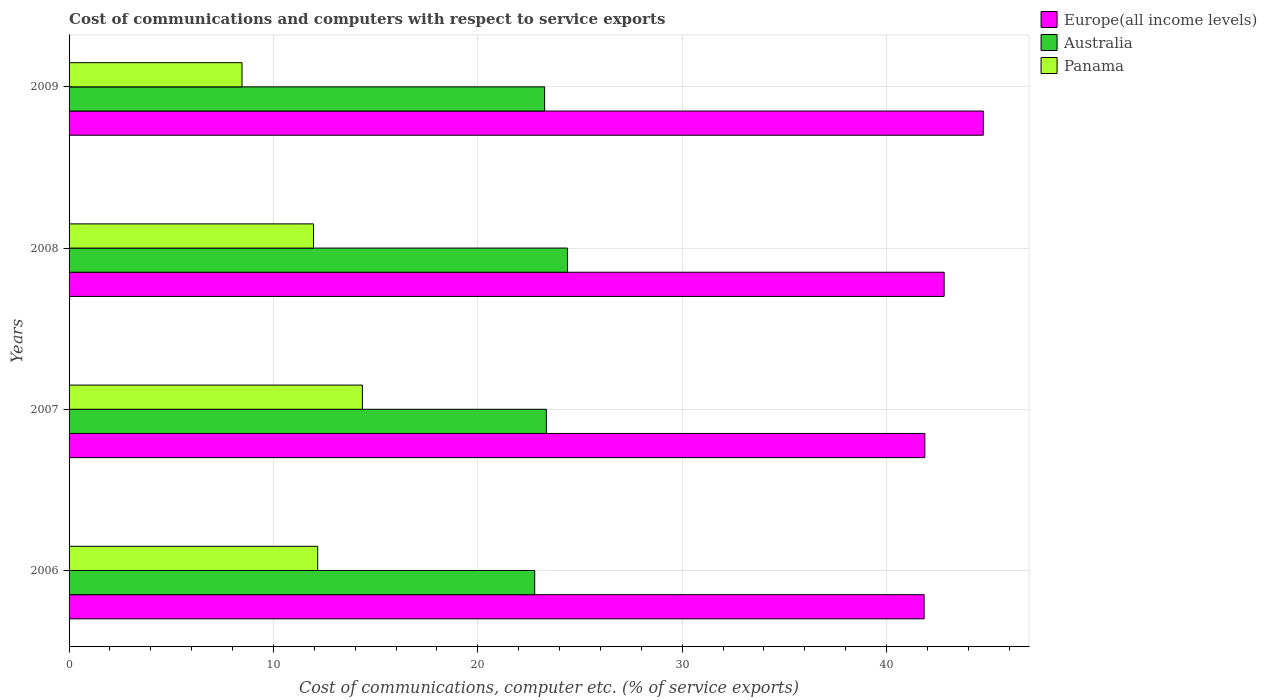How many different coloured bars are there?
Your answer should be compact. 3. How many bars are there on the 1st tick from the top?
Your response must be concise. 3. How many bars are there on the 4th tick from the bottom?
Ensure brevity in your answer.  3. What is the label of the 1st group of bars from the top?
Give a very brief answer. 2009. In how many cases, is the number of bars for a given year not equal to the number of legend labels?
Offer a very short reply. 0. What is the cost of communications and computers in Europe(all income levels) in 2007?
Keep it short and to the point. 41.88. Across all years, what is the maximum cost of communications and computers in Australia?
Give a very brief answer. 24.39. Across all years, what is the minimum cost of communications and computers in Europe(all income levels)?
Your answer should be compact. 41.84. In which year was the cost of communications and computers in Australia maximum?
Your answer should be very brief. 2008. In which year was the cost of communications and computers in Europe(all income levels) minimum?
Your answer should be compact. 2006. What is the total cost of communications and computers in Europe(all income levels) in the graph?
Offer a terse response. 171.28. What is the difference between the cost of communications and computers in Panama in 2007 and that in 2008?
Your answer should be compact. 2.39. What is the difference between the cost of communications and computers in Europe(all income levels) in 2006 and the cost of communications and computers in Panama in 2009?
Give a very brief answer. 33.38. What is the average cost of communications and computers in Europe(all income levels) per year?
Offer a very short reply. 42.82. In the year 2007, what is the difference between the cost of communications and computers in Panama and cost of communications and computers in Australia?
Offer a terse response. -9. What is the ratio of the cost of communications and computers in Panama in 2006 to that in 2008?
Offer a very short reply. 1.02. Is the cost of communications and computers in Panama in 2006 less than that in 2009?
Give a very brief answer. No. What is the difference between the highest and the second highest cost of communications and computers in Panama?
Give a very brief answer. 2.19. What is the difference between the highest and the lowest cost of communications and computers in Europe(all income levels)?
Keep it short and to the point. 2.9. What does the 2nd bar from the top in 2009 represents?
Your answer should be very brief. Australia. What does the 1st bar from the bottom in 2008 represents?
Offer a terse response. Europe(all income levels). Is it the case that in every year, the sum of the cost of communications and computers in Australia and cost of communications and computers in Panama is greater than the cost of communications and computers in Europe(all income levels)?
Keep it short and to the point. No. How many bars are there?
Give a very brief answer. 12. Are all the bars in the graph horizontal?
Make the answer very short. Yes. What is the difference between two consecutive major ticks on the X-axis?
Offer a terse response. 10. Where does the legend appear in the graph?
Give a very brief answer. Top right. What is the title of the graph?
Your answer should be compact. Cost of communications and computers with respect to service exports. What is the label or title of the X-axis?
Offer a terse response. Cost of communications, computer etc. (% of service exports). What is the label or title of the Y-axis?
Ensure brevity in your answer.  Years. What is the Cost of communications, computer etc. (% of service exports) of Europe(all income levels) in 2006?
Offer a terse response. 41.84. What is the Cost of communications, computer etc. (% of service exports) in Australia in 2006?
Make the answer very short. 22.79. What is the Cost of communications, computer etc. (% of service exports) in Panama in 2006?
Ensure brevity in your answer.  12.17. What is the Cost of communications, computer etc. (% of service exports) in Europe(all income levels) in 2007?
Your answer should be very brief. 41.88. What is the Cost of communications, computer etc. (% of service exports) of Australia in 2007?
Your answer should be very brief. 23.36. What is the Cost of communications, computer etc. (% of service exports) of Panama in 2007?
Your response must be concise. 14.35. What is the Cost of communications, computer etc. (% of service exports) of Europe(all income levels) in 2008?
Give a very brief answer. 42.82. What is the Cost of communications, computer etc. (% of service exports) in Australia in 2008?
Ensure brevity in your answer.  24.39. What is the Cost of communications, computer etc. (% of service exports) of Panama in 2008?
Give a very brief answer. 11.96. What is the Cost of communications, computer etc. (% of service exports) of Europe(all income levels) in 2009?
Keep it short and to the point. 44.74. What is the Cost of communications, computer etc. (% of service exports) of Australia in 2009?
Offer a very short reply. 23.27. What is the Cost of communications, computer etc. (% of service exports) in Panama in 2009?
Offer a terse response. 8.46. Across all years, what is the maximum Cost of communications, computer etc. (% of service exports) of Europe(all income levels)?
Your answer should be very brief. 44.74. Across all years, what is the maximum Cost of communications, computer etc. (% of service exports) of Australia?
Provide a succinct answer. 24.39. Across all years, what is the maximum Cost of communications, computer etc. (% of service exports) of Panama?
Your response must be concise. 14.35. Across all years, what is the minimum Cost of communications, computer etc. (% of service exports) in Europe(all income levels)?
Offer a terse response. 41.84. Across all years, what is the minimum Cost of communications, computer etc. (% of service exports) in Australia?
Give a very brief answer. 22.79. Across all years, what is the minimum Cost of communications, computer etc. (% of service exports) of Panama?
Give a very brief answer. 8.46. What is the total Cost of communications, computer etc. (% of service exports) in Europe(all income levels) in the graph?
Offer a terse response. 171.28. What is the total Cost of communications, computer etc. (% of service exports) in Australia in the graph?
Your response must be concise. 93.81. What is the total Cost of communications, computer etc. (% of service exports) of Panama in the graph?
Offer a terse response. 46.94. What is the difference between the Cost of communications, computer etc. (% of service exports) in Europe(all income levels) in 2006 and that in 2007?
Offer a very short reply. -0.04. What is the difference between the Cost of communications, computer etc. (% of service exports) in Australia in 2006 and that in 2007?
Give a very brief answer. -0.57. What is the difference between the Cost of communications, computer etc. (% of service exports) of Panama in 2006 and that in 2007?
Provide a short and direct response. -2.19. What is the difference between the Cost of communications, computer etc. (% of service exports) of Europe(all income levels) in 2006 and that in 2008?
Offer a very short reply. -0.98. What is the difference between the Cost of communications, computer etc. (% of service exports) in Australia in 2006 and that in 2008?
Offer a terse response. -1.61. What is the difference between the Cost of communications, computer etc. (% of service exports) of Panama in 2006 and that in 2008?
Give a very brief answer. 0.2. What is the difference between the Cost of communications, computer etc. (% of service exports) of Europe(all income levels) in 2006 and that in 2009?
Your answer should be compact. -2.9. What is the difference between the Cost of communications, computer etc. (% of service exports) in Australia in 2006 and that in 2009?
Your answer should be compact. -0.48. What is the difference between the Cost of communications, computer etc. (% of service exports) of Panama in 2006 and that in 2009?
Give a very brief answer. 3.7. What is the difference between the Cost of communications, computer etc. (% of service exports) of Europe(all income levels) in 2007 and that in 2008?
Keep it short and to the point. -0.94. What is the difference between the Cost of communications, computer etc. (% of service exports) of Australia in 2007 and that in 2008?
Ensure brevity in your answer.  -1.04. What is the difference between the Cost of communications, computer etc. (% of service exports) of Panama in 2007 and that in 2008?
Make the answer very short. 2.39. What is the difference between the Cost of communications, computer etc. (% of service exports) in Europe(all income levels) in 2007 and that in 2009?
Offer a terse response. -2.86. What is the difference between the Cost of communications, computer etc. (% of service exports) in Australia in 2007 and that in 2009?
Offer a terse response. 0.09. What is the difference between the Cost of communications, computer etc. (% of service exports) of Panama in 2007 and that in 2009?
Make the answer very short. 5.89. What is the difference between the Cost of communications, computer etc. (% of service exports) in Europe(all income levels) in 2008 and that in 2009?
Your answer should be very brief. -1.92. What is the difference between the Cost of communications, computer etc. (% of service exports) in Australia in 2008 and that in 2009?
Offer a terse response. 1.12. What is the difference between the Cost of communications, computer etc. (% of service exports) in Panama in 2008 and that in 2009?
Provide a short and direct response. 3.5. What is the difference between the Cost of communications, computer etc. (% of service exports) of Europe(all income levels) in 2006 and the Cost of communications, computer etc. (% of service exports) of Australia in 2007?
Offer a very short reply. 18.48. What is the difference between the Cost of communications, computer etc. (% of service exports) of Europe(all income levels) in 2006 and the Cost of communications, computer etc. (% of service exports) of Panama in 2007?
Your answer should be very brief. 27.49. What is the difference between the Cost of communications, computer etc. (% of service exports) of Australia in 2006 and the Cost of communications, computer etc. (% of service exports) of Panama in 2007?
Offer a terse response. 8.43. What is the difference between the Cost of communications, computer etc. (% of service exports) of Europe(all income levels) in 2006 and the Cost of communications, computer etc. (% of service exports) of Australia in 2008?
Give a very brief answer. 17.45. What is the difference between the Cost of communications, computer etc. (% of service exports) in Europe(all income levels) in 2006 and the Cost of communications, computer etc. (% of service exports) in Panama in 2008?
Offer a very short reply. 29.88. What is the difference between the Cost of communications, computer etc. (% of service exports) in Australia in 2006 and the Cost of communications, computer etc. (% of service exports) in Panama in 2008?
Ensure brevity in your answer.  10.82. What is the difference between the Cost of communications, computer etc. (% of service exports) of Europe(all income levels) in 2006 and the Cost of communications, computer etc. (% of service exports) of Australia in 2009?
Provide a succinct answer. 18.57. What is the difference between the Cost of communications, computer etc. (% of service exports) in Europe(all income levels) in 2006 and the Cost of communications, computer etc. (% of service exports) in Panama in 2009?
Keep it short and to the point. 33.38. What is the difference between the Cost of communications, computer etc. (% of service exports) in Australia in 2006 and the Cost of communications, computer etc. (% of service exports) in Panama in 2009?
Make the answer very short. 14.32. What is the difference between the Cost of communications, computer etc. (% of service exports) in Europe(all income levels) in 2007 and the Cost of communications, computer etc. (% of service exports) in Australia in 2008?
Provide a succinct answer. 17.49. What is the difference between the Cost of communications, computer etc. (% of service exports) in Europe(all income levels) in 2007 and the Cost of communications, computer etc. (% of service exports) in Panama in 2008?
Your answer should be very brief. 29.92. What is the difference between the Cost of communications, computer etc. (% of service exports) in Australia in 2007 and the Cost of communications, computer etc. (% of service exports) in Panama in 2008?
Offer a very short reply. 11.39. What is the difference between the Cost of communications, computer etc. (% of service exports) in Europe(all income levels) in 2007 and the Cost of communications, computer etc. (% of service exports) in Australia in 2009?
Your answer should be compact. 18.61. What is the difference between the Cost of communications, computer etc. (% of service exports) in Europe(all income levels) in 2007 and the Cost of communications, computer etc. (% of service exports) in Panama in 2009?
Your answer should be compact. 33.42. What is the difference between the Cost of communications, computer etc. (% of service exports) of Australia in 2007 and the Cost of communications, computer etc. (% of service exports) of Panama in 2009?
Keep it short and to the point. 14.89. What is the difference between the Cost of communications, computer etc. (% of service exports) of Europe(all income levels) in 2008 and the Cost of communications, computer etc. (% of service exports) of Australia in 2009?
Keep it short and to the point. 19.55. What is the difference between the Cost of communications, computer etc. (% of service exports) in Europe(all income levels) in 2008 and the Cost of communications, computer etc. (% of service exports) in Panama in 2009?
Ensure brevity in your answer.  34.36. What is the difference between the Cost of communications, computer etc. (% of service exports) of Australia in 2008 and the Cost of communications, computer etc. (% of service exports) of Panama in 2009?
Give a very brief answer. 15.93. What is the average Cost of communications, computer etc. (% of service exports) of Europe(all income levels) per year?
Offer a terse response. 42.82. What is the average Cost of communications, computer etc. (% of service exports) in Australia per year?
Give a very brief answer. 23.45. What is the average Cost of communications, computer etc. (% of service exports) of Panama per year?
Ensure brevity in your answer.  11.74. In the year 2006, what is the difference between the Cost of communications, computer etc. (% of service exports) in Europe(all income levels) and Cost of communications, computer etc. (% of service exports) in Australia?
Provide a succinct answer. 19.06. In the year 2006, what is the difference between the Cost of communications, computer etc. (% of service exports) in Europe(all income levels) and Cost of communications, computer etc. (% of service exports) in Panama?
Provide a succinct answer. 29.68. In the year 2006, what is the difference between the Cost of communications, computer etc. (% of service exports) of Australia and Cost of communications, computer etc. (% of service exports) of Panama?
Your answer should be very brief. 10.62. In the year 2007, what is the difference between the Cost of communications, computer etc. (% of service exports) in Europe(all income levels) and Cost of communications, computer etc. (% of service exports) in Australia?
Your response must be concise. 18.52. In the year 2007, what is the difference between the Cost of communications, computer etc. (% of service exports) of Europe(all income levels) and Cost of communications, computer etc. (% of service exports) of Panama?
Your answer should be compact. 27.52. In the year 2007, what is the difference between the Cost of communications, computer etc. (% of service exports) of Australia and Cost of communications, computer etc. (% of service exports) of Panama?
Your answer should be compact. 9. In the year 2008, what is the difference between the Cost of communications, computer etc. (% of service exports) of Europe(all income levels) and Cost of communications, computer etc. (% of service exports) of Australia?
Provide a succinct answer. 18.43. In the year 2008, what is the difference between the Cost of communications, computer etc. (% of service exports) in Europe(all income levels) and Cost of communications, computer etc. (% of service exports) in Panama?
Offer a terse response. 30.86. In the year 2008, what is the difference between the Cost of communications, computer etc. (% of service exports) of Australia and Cost of communications, computer etc. (% of service exports) of Panama?
Offer a very short reply. 12.43. In the year 2009, what is the difference between the Cost of communications, computer etc. (% of service exports) in Europe(all income levels) and Cost of communications, computer etc. (% of service exports) in Australia?
Ensure brevity in your answer.  21.47. In the year 2009, what is the difference between the Cost of communications, computer etc. (% of service exports) of Europe(all income levels) and Cost of communications, computer etc. (% of service exports) of Panama?
Your answer should be compact. 36.28. In the year 2009, what is the difference between the Cost of communications, computer etc. (% of service exports) of Australia and Cost of communications, computer etc. (% of service exports) of Panama?
Your answer should be very brief. 14.81. What is the ratio of the Cost of communications, computer etc. (% of service exports) in Australia in 2006 to that in 2007?
Provide a succinct answer. 0.98. What is the ratio of the Cost of communications, computer etc. (% of service exports) in Panama in 2006 to that in 2007?
Give a very brief answer. 0.85. What is the ratio of the Cost of communications, computer etc. (% of service exports) in Europe(all income levels) in 2006 to that in 2008?
Your response must be concise. 0.98. What is the ratio of the Cost of communications, computer etc. (% of service exports) of Australia in 2006 to that in 2008?
Make the answer very short. 0.93. What is the ratio of the Cost of communications, computer etc. (% of service exports) in Panama in 2006 to that in 2008?
Keep it short and to the point. 1.02. What is the ratio of the Cost of communications, computer etc. (% of service exports) of Europe(all income levels) in 2006 to that in 2009?
Your answer should be very brief. 0.94. What is the ratio of the Cost of communications, computer etc. (% of service exports) in Australia in 2006 to that in 2009?
Offer a very short reply. 0.98. What is the ratio of the Cost of communications, computer etc. (% of service exports) of Panama in 2006 to that in 2009?
Your answer should be very brief. 1.44. What is the ratio of the Cost of communications, computer etc. (% of service exports) of Europe(all income levels) in 2007 to that in 2008?
Keep it short and to the point. 0.98. What is the ratio of the Cost of communications, computer etc. (% of service exports) of Australia in 2007 to that in 2008?
Keep it short and to the point. 0.96. What is the ratio of the Cost of communications, computer etc. (% of service exports) of Europe(all income levels) in 2007 to that in 2009?
Provide a succinct answer. 0.94. What is the ratio of the Cost of communications, computer etc. (% of service exports) of Australia in 2007 to that in 2009?
Your response must be concise. 1. What is the ratio of the Cost of communications, computer etc. (% of service exports) in Panama in 2007 to that in 2009?
Your answer should be compact. 1.7. What is the ratio of the Cost of communications, computer etc. (% of service exports) of Europe(all income levels) in 2008 to that in 2009?
Keep it short and to the point. 0.96. What is the ratio of the Cost of communications, computer etc. (% of service exports) of Australia in 2008 to that in 2009?
Offer a very short reply. 1.05. What is the ratio of the Cost of communications, computer etc. (% of service exports) in Panama in 2008 to that in 2009?
Your answer should be compact. 1.41. What is the difference between the highest and the second highest Cost of communications, computer etc. (% of service exports) in Europe(all income levels)?
Ensure brevity in your answer.  1.92. What is the difference between the highest and the second highest Cost of communications, computer etc. (% of service exports) in Australia?
Offer a terse response. 1.04. What is the difference between the highest and the second highest Cost of communications, computer etc. (% of service exports) of Panama?
Keep it short and to the point. 2.19. What is the difference between the highest and the lowest Cost of communications, computer etc. (% of service exports) of Europe(all income levels)?
Provide a succinct answer. 2.9. What is the difference between the highest and the lowest Cost of communications, computer etc. (% of service exports) of Australia?
Offer a terse response. 1.61. What is the difference between the highest and the lowest Cost of communications, computer etc. (% of service exports) in Panama?
Your answer should be very brief. 5.89. 